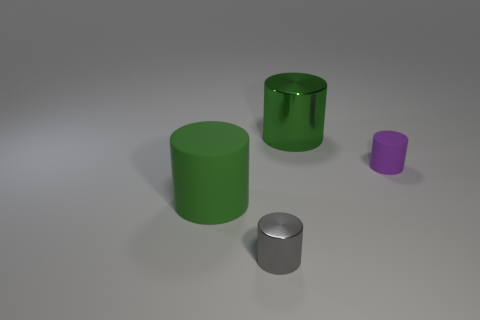Subtract all tiny gray cylinders. How many cylinders are left? 3 Subtract all green cylinders. How many cylinders are left? 2 Add 1 gray shiny objects. How many objects exist? 5 Subtract all brown spheres. How many green cylinders are left? 2 Add 3 small matte balls. How many small matte balls exist? 3 Subtract 0 yellow cylinders. How many objects are left? 4 Subtract 1 cylinders. How many cylinders are left? 3 Subtract all yellow cylinders. Subtract all brown blocks. How many cylinders are left? 4 Subtract all yellow metal cylinders. Subtract all green metallic objects. How many objects are left? 3 Add 2 green cylinders. How many green cylinders are left? 4 